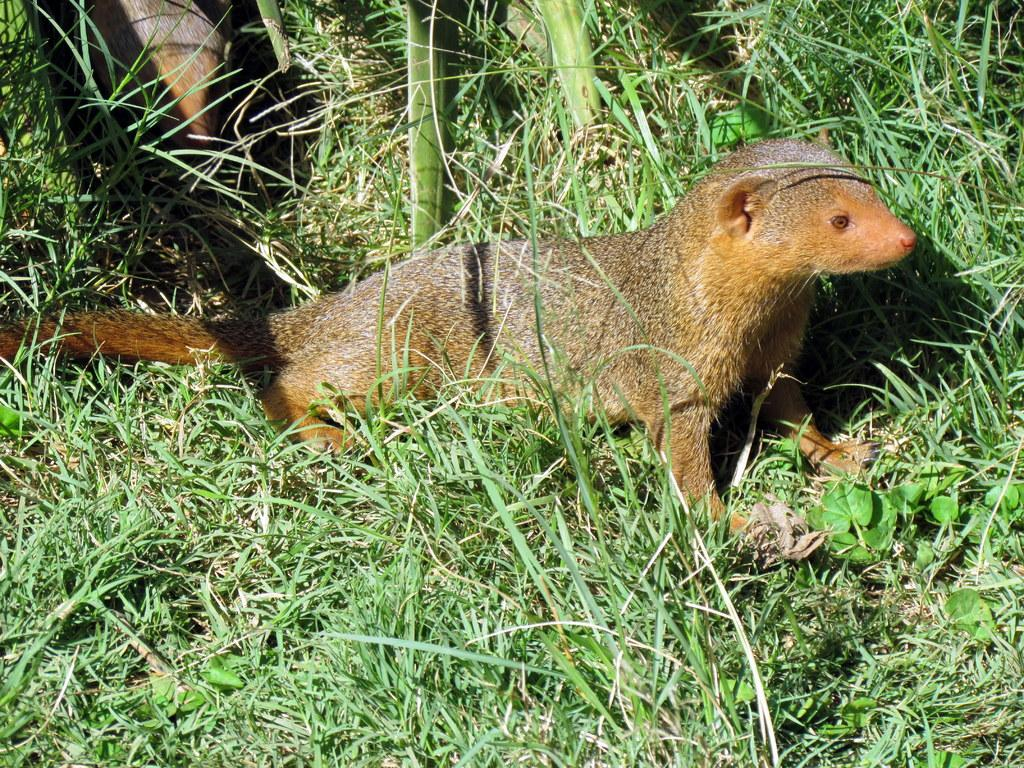What type of vegetation is present on the ground in the image? There is grass and small plants on the ground in the image. How many animals can be seen in the image? There are two animals in the image. What type of sticks are the animals using to cook the meat in the image? There is no indication of sticks or meat in the image; it only features grass, small plants, and two animals. Is there a volcano visible in the image? No, there is no volcano present in the image. 